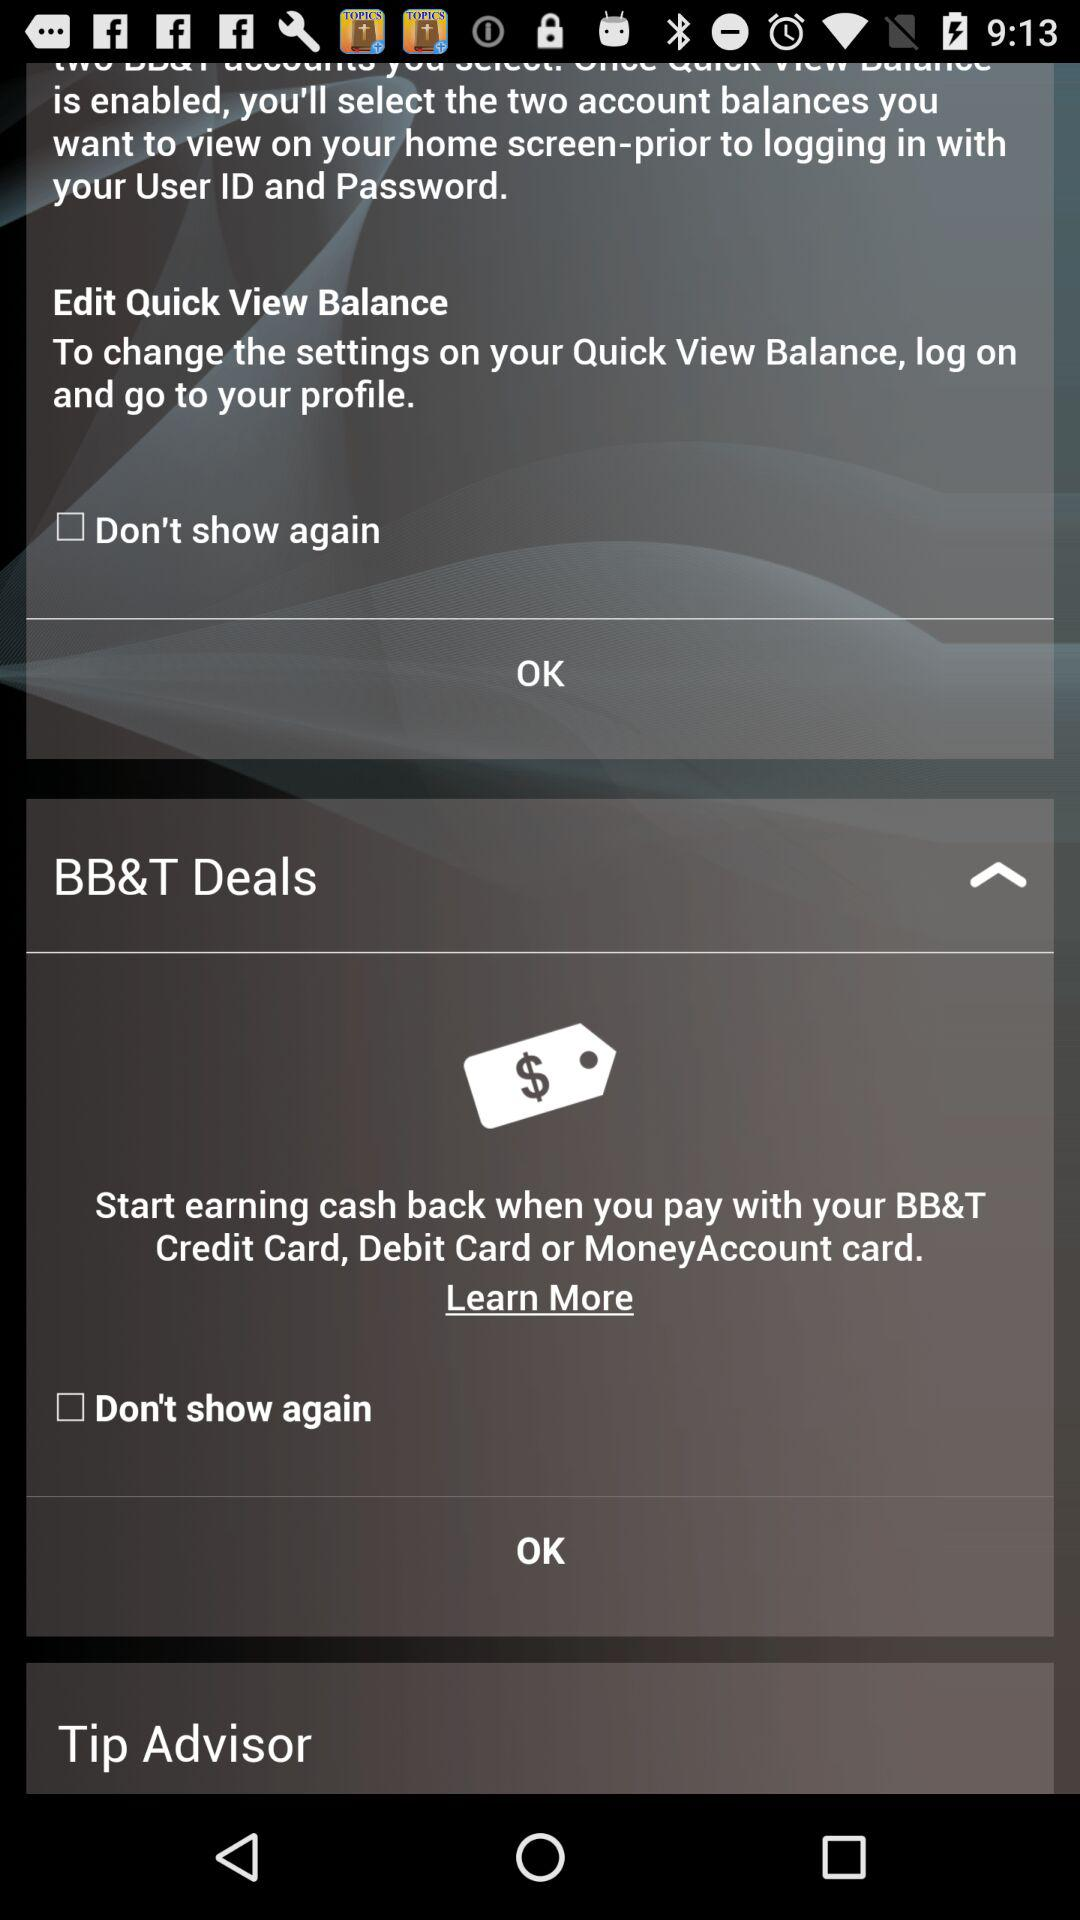What is the status of "Don't show again"? The status of "Don't show again" is "off". 